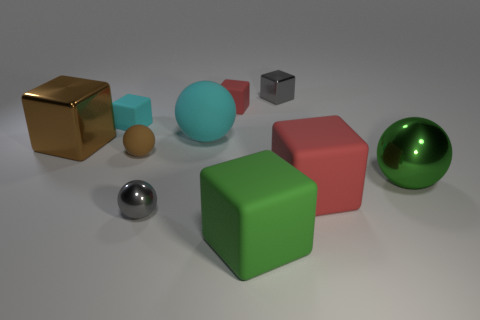Subtract all green rubber blocks. How many blocks are left? 5 Subtract all spheres. How many objects are left? 6 Subtract all red spheres. How many red cubes are left? 2 Subtract all cyan blocks. How many blocks are left? 5 Subtract 2 spheres. How many spheres are left? 2 Subtract all tiny gray metallic spheres. Subtract all big rubber spheres. How many objects are left? 8 Add 4 big green things. How many big green things are left? 6 Add 7 big gray matte cubes. How many big gray matte cubes exist? 7 Subtract 1 green spheres. How many objects are left? 9 Subtract all cyan cubes. Subtract all green balls. How many cubes are left? 5 